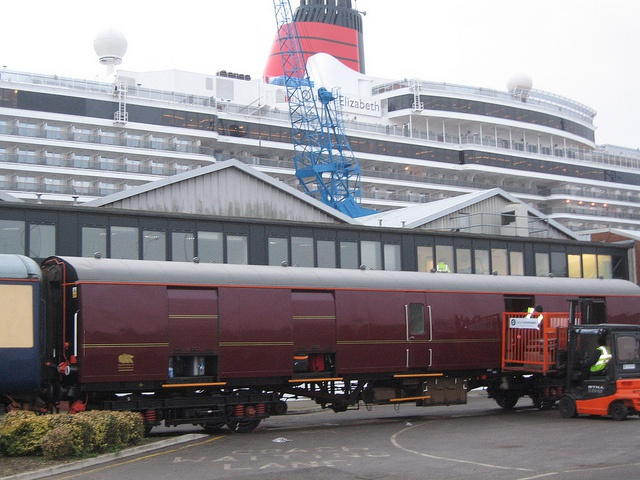Describe the objects in this image and their specific colors. I can see train in white, black, maroon, purple, and darkgray tones, people in white, black, olive, and darkgray tones, suitcase in black, maroon, and white tones, people in white, black, gray, and brown tones, and people in white, lightgreen, darkgray, lightgray, and khaki tones in this image. 